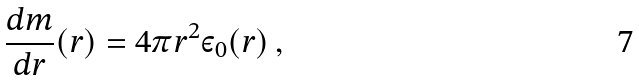Convert formula to latex. <formula><loc_0><loc_0><loc_500><loc_500>\frac { d m } { d r } ( r ) = 4 \pi r ^ { 2 } \varepsilon _ { 0 } ( r ) \, ,</formula> 